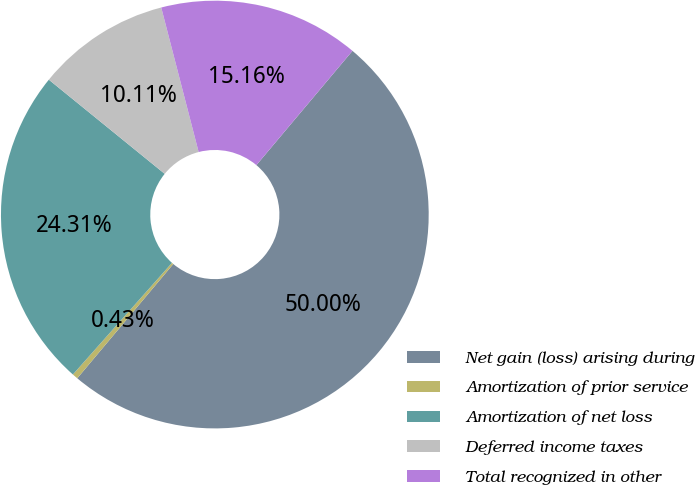Convert chart to OTSL. <chart><loc_0><loc_0><loc_500><loc_500><pie_chart><fcel>Net gain (loss) arising during<fcel>Amortization of prior service<fcel>Amortization of net loss<fcel>Deferred income taxes<fcel>Total recognized in other<nl><fcel>50.0%<fcel>0.43%<fcel>24.31%<fcel>10.11%<fcel>15.16%<nl></chart> 